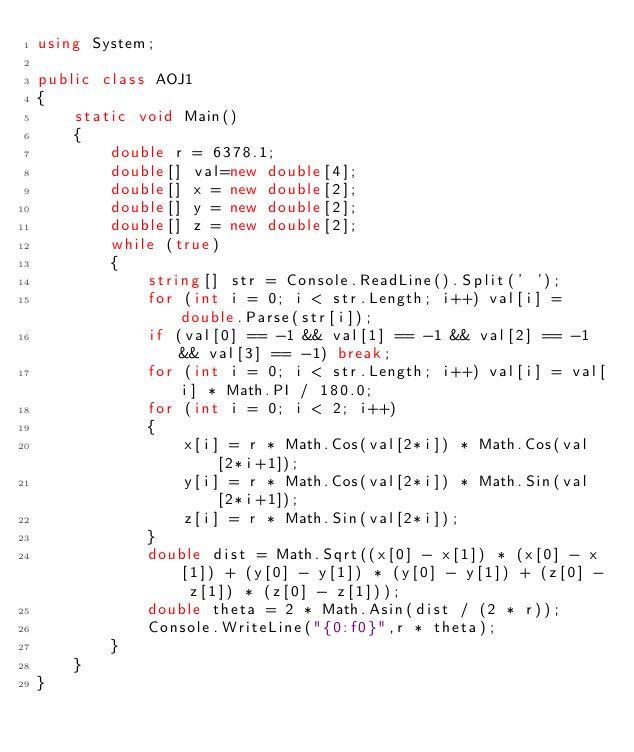<code> <loc_0><loc_0><loc_500><loc_500><_C#_>using System;

public class AOJ1
{
    static void Main()
    {
        double r = 6378.1;
        double[] val=new double[4];
        double[] x = new double[2];
        double[] y = new double[2];
        double[] z = new double[2];
        while (true)
        {
            string[] str = Console.ReadLine().Split(' ');
            for (int i = 0; i < str.Length; i++) val[i] = double.Parse(str[i]);
            if (val[0] == -1 && val[1] == -1 && val[2] == -1 && val[3] == -1) break;
            for (int i = 0; i < str.Length; i++) val[i] = val[i] * Math.PI / 180.0;
            for (int i = 0; i < 2; i++)
            {
                x[i] = r * Math.Cos(val[2*i]) * Math.Cos(val[2*i+1]);
                y[i] = r * Math.Cos(val[2*i]) * Math.Sin(val[2*i+1]);
                z[i] = r * Math.Sin(val[2*i]);
            }
            double dist = Math.Sqrt((x[0] - x[1]) * (x[0] - x[1]) + (y[0] - y[1]) * (y[0] - y[1]) + (z[0] - z[1]) * (z[0] - z[1]));
            double theta = 2 * Math.Asin(dist / (2 * r));
            Console.WriteLine("{0:f0}",r * theta);
        }
    }
}</code> 